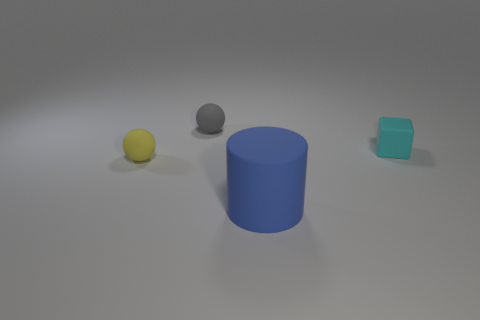There is a rubber ball behind the small thing that is on the right side of the big matte object; what is its color?
Offer a very short reply. Gray. How many rubber spheres are in front of the tiny ball behind the tiny rubber object that is right of the blue matte cylinder?
Ensure brevity in your answer.  1. There is a gray rubber thing; are there any rubber balls in front of it?
Offer a terse response. Yes. How many balls are gray objects or yellow matte things?
Your answer should be compact. 2. What number of rubber things are on the right side of the small gray sphere and behind the tiny yellow matte sphere?
Your answer should be very brief. 1. Are there an equal number of matte blocks left of the small gray sphere and blue matte objects to the left of the blue thing?
Your answer should be compact. Yes. There is a object that is to the right of the blue matte object; is its shape the same as the blue object?
Give a very brief answer. No. There is a matte object in front of the rubber sphere that is in front of the matte thing right of the blue cylinder; what is its shape?
Make the answer very short. Cylinder. Are there fewer big yellow spheres than small cyan cubes?
Make the answer very short. Yes. Do the yellow object and the object behind the cyan thing have the same shape?
Your answer should be very brief. Yes. 